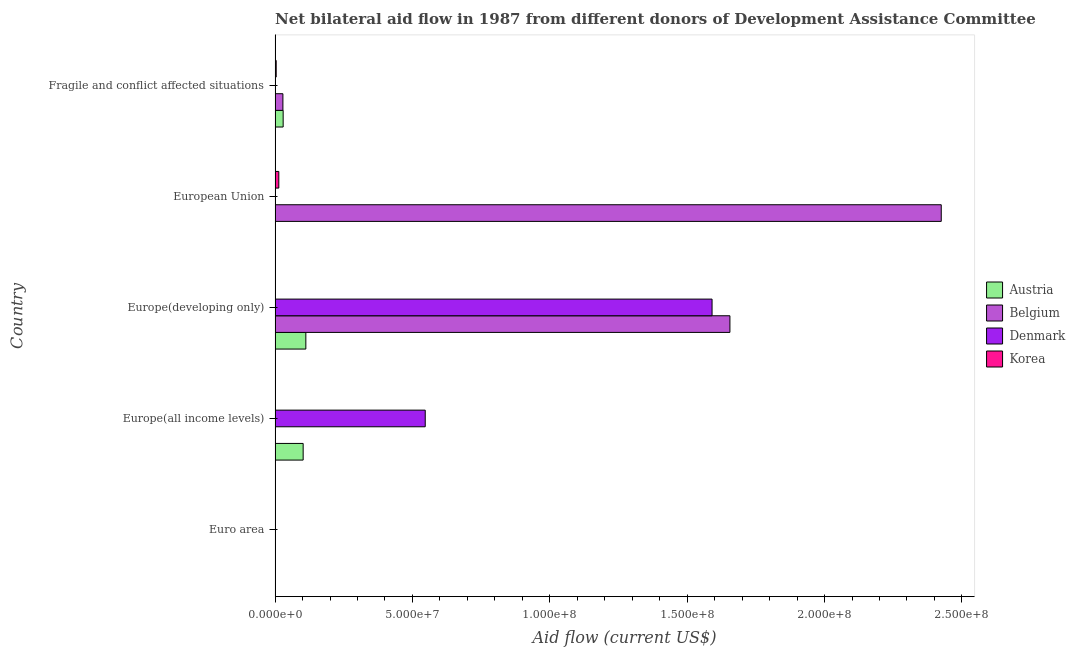How many different coloured bars are there?
Ensure brevity in your answer.  4. Are the number of bars per tick equal to the number of legend labels?
Ensure brevity in your answer.  No. Are the number of bars on each tick of the Y-axis equal?
Offer a very short reply. No. How many bars are there on the 2nd tick from the top?
Keep it short and to the point. 2. How many bars are there on the 2nd tick from the bottom?
Provide a succinct answer. 3. What is the label of the 1st group of bars from the top?
Provide a succinct answer. Fragile and conflict affected situations. What is the amount of aid given by belgium in Europe(developing only)?
Your response must be concise. 1.66e+08. Across all countries, what is the maximum amount of aid given by belgium?
Ensure brevity in your answer.  2.42e+08. Across all countries, what is the minimum amount of aid given by korea?
Provide a succinct answer. 4.00e+04. In which country was the amount of aid given by denmark maximum?
Provide a succinct answer. Europe(developing only). What is the total amount of aid given by korea in the graph?
Provide a succinct answer. 2.04e+06. What is the difference between the amount of aid given by korea in Europe(all income levels) and that in Europe(developing only)?
Provide a succinct answer. 10000. What is the difference between the amount of aid given by korea in Europe(all income levels) and the amount of aid given by austria in Fragile and conflict affected situations?
Your answer should be compact. -2.82e+06. What is the average amount of aid given by denmark per country?
Keep it short and to the point. 4.27e+07. What is the difference between the amount of aid given by belgium and amount of aid given by korea in Europe(developing only)?
Offer a very short reply. 1.65e+08. In how many countries, is the amount of aid given by korea greater than 170000000 US$?
Keep it short and to the point. 0. What is the ratio of the amount of aid given by korea in Euro area to that in Europe(all income levels)?
Offer a very short reply. 0.33. What is the difference between the highest and the second highest amount of aid given by austria?
Your answer should be very brief. 9.80e+05. What is the difference between the highest and the lowest amount of aid given by denmark?
Your answer should be very brief. 1.59e+08. In how many countries, is the amount of aid given by korea greater than the average amount of aid given by korea taken over all countries?
Offer a very short reply. 2. Is the sum of the amount of aid given by korea in Europe(all income levels) and Europe(developing only) greater than the maximum amount of aid given by austria across all countries?
Offer a very short reply. No. Is it the case that in every country, the sum of the amount of aid given by belgium and amount of aid given by korea is greater than the sum of amount of aid given by austria and amount of aid given by denmark?
Give a very brief answer. No. What is the difference between two consecutive major ticks on the X-axis?
Offer a terse response. 5.00e+07. How many legend labels are there?
Offer a very short reply. 4. How are the legend labels stacked?
Provide a succinct answer. Vertical. What is the title of the graph?
Keep it short and to the point. Net bilateral aid flow in 1987 from different donors of Development Assistance Committee. What is the label or title of the X-axis?
Make the answer very short. Aid flow (current US$). What is the Aid flow (current US$) of Belgium in Euro area?
Provide a short and direct response. 0. What is the Aid flow (current US$) in Denmark in Euro area?
Your response must be concise. 0. What is the Aid flow (current US$) in Korea in Euro area?
Keep it short and to the point. 4.00e+04. What is the Aid flow (current US$) of Austria in Europe(all income levels)?
Offer a very short reply. 1.02e+07. What is the Aid flow (current US$) in Denmark in Europe(all income levels)?
Provide a succinct answer. 5.46e+07. What is the Aid flow (current US$) of Korea in Europe(all income levels)?
Make the answer very short. 1.20e+05. What is the Aid flow (current US$) of Austria in Europe(developing only)?
Give a very brief answer. 1.12e+07. What is the Aid flow (current US$) in Belgium in Europe(developing only)?
Provide a short and direct response. 1.66e+08. What is the Aid flow (current US$) in Denmark in Europe(developing only)?
Provide a short and direct response. 1.59e+08. What is the Aid flow (current US$) in Korea in Europe(developing only)?
Offer a terse response. 1.10e+05. What is the Aid flow (current US$) of Belgium in European Union?
Provide a short and direct response. 2.42e+08. What is the Aid flow (current US$) of Korea in European Union?
Offer a terse response. 1.36e+06. What is the Aid flow (current US$) in Austria in Fragile and conflict affected situations?
Provide a succinct answer. 2.94e+06. What is the Aid flow (current US$) of Belgium in Fragile and conflict affected situations?
Ensure brevity in your answer.  2.85e+06. Across all countries, what is the maximum Aid flow (current US$) in Austria?
Ensure brevity in your answer.  1.12e+07. Across all countries, what is the maximum Aid flow (current US$) of Belgium?
Ensure brevity in your answer.  2.42e+08. Across all countries, what is the maximum Aid flow (current US$) of Denmark?
Keep it short and to the point. 1.59e+08. Across all countries, what is the maximum Aid flow (current US$) in Korea?
Ensure brevity in your answer.  1.36e+06. Across all countries, what is the minimum Aid flow (current US$) in Belgium?
Offer a very short reply. 0. Across all countries, what is the minimum Aid flow (current US$) of Denmark?
Your answer should be compact. 0. What is the total Aid flow (current US$) of Austria in the graph?
Keep it short and to the point. 2.44e+07. What is the total Aid flow (current US$) of Belgium in the graph?
Give a very brief answer. 4.11e+08. What is the total Aid flow (current US$) in Denmark in the graph?
Offer a very short reply. 2.14e+08. What is the total Aid flow (current US$) in Korea in the graph?
Ensure brevity in your answer.  2.04e+06. What is the difference between the Aid flow (current US$) of Korea in Euro area and that in Europe(all income levels)?
Offer a very short reply. -8.00e+04. What is the difference between the Aid flow (current US$) of Korea in Euro area and that in Europe(developing only)?
Keep it short and to the point. -7.00e+04. What is the difference between the Aid flow (current US$) of Korea in Euro area and that in European Union?
Keep it short and to the point. -1.32e+06. What is the difference between the Aid flow (current US$) of Korea in Euro area and that in Fragile and conflict affected situations?
Ensure brevity in your answer.  -3.70e+05. What is the difference between the Aid flow (current US$) of Austria in Europe(all income levels) and that in Europe(developing only)?
Make the answer very short. -9.80e+05. What is the difference between the Aid flow (current US$) of Denmark in Europe(all income levels) and that in Europe(developing only)?
Your response must be concise. -1.04e+08. What is the difference between the Aid flow (current US$) of Korea in Europe(all income levels) and that in Europe(developing only)?
Offer a very short reply. 10000. What is the difference between the Aid flow (current US$) of Korea in Europe(all income levels) and that in European Union?
Offer a very short reply. -1.24e+06. What is the difference between the Aid flow (current US$) in Austria in Europe(all income levels) and that in Fragile and conflict affected situations?
Provide a succinct answer. 7.28e+06. What is the difference between the Aid flow (current US$) of Belgium in Europe(developing only) and that in European Union?
Provide a succinct answer. -7.69e+07. What is the difference between the Aid flow (current US$) in Korea in Europe(developing only) and that in European Union?
Offer a terse response. -1.25e+06. What is the difference between the Aid flow (current US$) of Austria in Europe(developing only) and that in Fragile and conflict affected situations?
Offer a terse response. 8.26e+06. What is the difference between the Aid flow (current US$) in Belgium in Europe(developing only) and that in Fragile and conflict affected situations?
Ensure brevity in your answer.  1.63e+08. What is the difference between the Aid flow (current US$) in Belgium in European Union and that in Fragile and conflict affected situations?
Your response must be concise. 2.40e+08. What is the difference between the Aid flow (current US$) of Korea in European Union and that in Fragile and conflict affected situations?
Give a very brief answer. 9.50e+05. What is the difference between the Aid flow (current US$) in Austria in Europe(all income levels) and the Aid flow (current US$) in Belgium in Europe(developing only)?
Your answer should be very brief. -1.55e+08. What is the difference between the Aid flow (current US$) in Austria in Europe(all income levels) and the Aid flow (current US$) in Denmark in Europe(developing only)?
Provide a short and direct response. -1.49e+08. What is the difference between the Aid flow (current US$) in Austria in Europe(all income levels) and the Aid flow (current US$) in Korea in Europe(developing only)?
Offer a very short reply. 1.01e+07. What is the difference between the Aid flow (current US$) in Denmark in Europe(all income levels) and the Aid flow (current US$) in Korea in Europe(developing only)?
Provide a short and direct response. 5.45e+07. What is the difference between the Aid flow (current US$) of Austria in Europe(all income levels) and the Aid flow (current US$) of Belgium in European Union?
Give a very brief answer. -2.32e+08. What is the difference between the Aid flow (current US$) in Austria in Europe(all income levels) and the Aid flow (current US$) in Korea in European Union?
Offer a very short reply. 8.86e+06. What is the difference between the Aid flow (current US$) in Denmark in Europe(all income levels) and the Aid flow (current US$) in Korea in European Union?
Ensure brevity in your answer.  5.33e+07. What is the difference between the Aid flow (current US$) of Austria in Europe(all income levels) and the Aid flow (current US$) of Belgium in Fragile and conflict affected situations?
Your answer should be very brief. 7.37e+06. What is the difference between the Aid flow (current US$) in Austria in Europe(all income levels) and the Aid flow (current US$) in Korea in Fragile and conflict affected situations?
Provide a succinct answer. 9.81e+06. What is the difference between the Aid flow (current US$) in Denmark in Europe(all income levels) and the Aid flow (current US$) in Korea in Fragile and conflict affected situations?
Ensure brevity in your answer.  5.42e+07. What is the difference between the Aid flow (current US$) of Austria in Europe(developing only) and the Aid flow (current US$) of Belgium in European Union?
Ensure brevity in your answer.  -2.31e+08. What is the difference between the Aid flow (current US$) in Austria in Europe(developing only) and the Aid flow (current US$) in Korea in European Union?
Keep it short and to the point. 9.84e+06. What is the difference between the Aid flow (current US$) in Belgium in Europe(developing only) and the Aid flow (current US$) in Korea in European Union?
Your response must be concise. 1.64e+08. What is the difference between the Aid flow (current US$) in Denmark in Europe(developing only) and the Aid flow (current US$) in Korea in European Union?
Your answer should be compact. 1.58e+08. What is the difference between the Aid flow (current US$) in Austria in Europe(developing only) and the Aid flow (current US$) in Belgium in Fragile and conflict affected situations?
Your response must be concise. 8.35e+06. What is the difference between the Aid flow (current US$) in Austria in Europe(developing only) and the Aid flow (current US$) in Korea in Fragile and conflict affected situations?
Ensure brevity in your answer.  1.08e+07. What is the difference between the Aid flow (current US$) in Belgium in Europe(developing only) and the Aid flow (current US$) in Korea in Fragile and conflict affected situations?
Keep it short and to the point. 1.65e+08. What is the difference between the Aid flow (current US$) in Denmark in Europe(developing only) and the Aid flow (current US$) in Korea in Fragile and conflict affected situations?
Keep it short and to the point. 1.59e+08. What is the difference between the Aid flow (current US$) of Belgium in European Union and the Aid flow (current US$) of Korea in Fragile and conflict affected situations?
Keep it short and to the point. 2.42e+08. What is the average Aid flow (current US$) in Austria per country?
Your response must be concise. 4.87e+06. What is the average Aid flow (current US$) in Belgium per country?
Keep it short and to the point. 8.22e+07. What is the average Aid flow (current US$) of Denmark per country?
Provide a short and direct response. 4.27e+07. What is the average Aid flow (current US$) of Korea per country?
Offer a terse response. 4.08e+05. What is the difference between the Aid flow (current US$) of Austria and Aid flow (current US$) of Denmark in Europe(all income levels)?
Offer a very short reply. -4.44e+07. What is the difference between the Aid flow (current US$) in Austria and Aid flow (current US$) in Korea in Europe(all income levels)?
Offer a very short reply. 1.01e+07. What is the difference between the Aid flow (current US$) of Denmark and Aid flow (current US$) of Korea in Europe(all income levels)?
Provide a succinct answer. 5.45e+07. What is the difference between the Aid flow (current US$) of Austria and Aid flow (current US$) of Belgium in Europe(developing only)?
Give a very brief answer. -1.54e+08. What is the difference between the Aid flow (current US$) of Austria and Aid flow (current US$) of Denmark in Europe(developing only)?
Give a very brief answer. -1.48e+08. What is the difference between the Aid flow (current US$) of Austria and Aid flow (current US$) of Korea in Europe(developing only)?
Your response must be concise. 1.11e+07. What is the difference between the Aid flow (current US$) of Belgium and Aid flow (current US$) of Denmark in Europe(developing only)?
Provide a succinct answer. 6.50e+06. What is the difference between the Aid flow (current US$) in Belgium and Aid flow (current US$) in Korea in Europe(developing only)?
Your response must be concise. 1.65e+08. What is the difference between the Aid flow (current US$) of Denmark and Aid flow (current US$) of Korea in Europe(developing only)?
Your answer should be very brief. 1.59e+08. What is the difference between the Aid flow (current US$) of Belgium and Aid flow (current US$) of Korea in European Union?
Ensure brevity in your answer.  2.41e+08. What is the difference between the Aid flow (current US$) of Austria and Aid flow (current US$) of Belgium in Fragile and conflict affected situations?
Your answer should be very brief. 9.00e+04. What is the difference between the Aid flow (current US$) of Austria and Aid flow (current US$) of Korea in Fragile and conflict affected situations?
Your response must be concise. 2.53e+06. What is the difference between the Aid flow (current US$) in Belgium and Aid flow (current US$) in Korea in Fragile and conflict affected situations?
Your answer should be compact. 2.44e+06. What is the ratio of the Aid flow (current US$) in Korea in Euro area to that in Europe(all income levels)?
Give a very brief answer. 0.33. What is the ratio of the Aid flow (current US$) in Korea in Euro area to that in Europe(developing only)?
Offer a terse response. 0.36. What is the ratio of the Aid flow (current US$) in Korea in Euro area to that in European Union?
Provide a succinct answer. 0.03. What is the ratio of the Aid flow (current US$) of Korea in Euro area to that in Fragile and conflict affected situations?
Your answer should be compact. 0.1. What is the ratio of the Aid flow (current US$) in Austria in Europe(all income levels) to that in Europe(developing only)?
Offer a very short reply. 0.91. What is the ratio of the Aid flow (current US$) in Denmark in Europe(all income levels) to that in Europe(developing only)?
Make the answer very short. 0.34. What is the ratio of the Aid flow (current US$) in Korea in Europe(all income levels) to that in European Union?
Give a very brief answer. 0.09. What is the ratio of the Aid flow (current US$) in Austria in Europe(all income levels) to that in Fragile and conflict affected situations?
Provide a short and direct response. 3.48. What is the ratio of the Aid flow (current US$) of Korea in Europe(all income levels) to that in Fragile and conflict affected situations?
Your answer should be very brief. 0.29. What is the ratio of the Aid flow (current US$) in Belgium in Europe(developing only) to that in European Union?
Provide a short and direct response. 0.68. What is the ratio of the Aid flow (current US$) in Korea in Europe(developing only) to that in European Union?
Offer a very short reply. 0.08. What is the ratio of the Aid flow (current US$) in Austria in Europe(developing only) to that in Fragile and conflict affected situations?
Provide a short and direct response. 3.81. What is the ratio of the Aid flow (current US$) in Belgium in Europe(developing only) to that in Fragile and conflict affected situations?
Your response must be concise. 58.09. What is the ratio of the Aid flow (current US$) of Korea in Europe(developing only) to that in Fragile and conflict affected situations?
Ensure brevity in your answer.  0.27. What is the ratio of the Aid flow (current US$) in Belgium in European Union to that in Fragile and conflict affected situations?
Your response must be concise. 85.08. What is the ratio of the Aid flow (current US$) of Korea in European Union to that in Fragile and conflict affected situations?
Give a very brief answer. 3.32. What is the difference between the highest and the second highest Aid flow (current US$) of Austria?
Ensure brevity in your answer.  9.80e+05. What is the difference between the highest and the second highest Aid flow (current US$) in Belgium?
Offer a very short reply. 7.69e+07. What is the difference between the highest and the second highest Aid flow (current US$) in Korea?
Your answer should be very brief. 9.50e+05. What is the difference between the highest and the lowest Aid flow (current US$) of Austria?
Your answer should be very brief. 1.12e+07. What is the difference between the highest and the lowest Aid flow (current US$) of Belgium?
Offer a very short reply. 2.42e+08. What is the difference between the highest and the lowest Aid flow (current US$) in Denmark?
Give a very brief answer. 1.59e+08. What is the difference between the highest and the lowest Aid flow (current US$) in Korea?
Make the answer very short. 1.32e+06. 